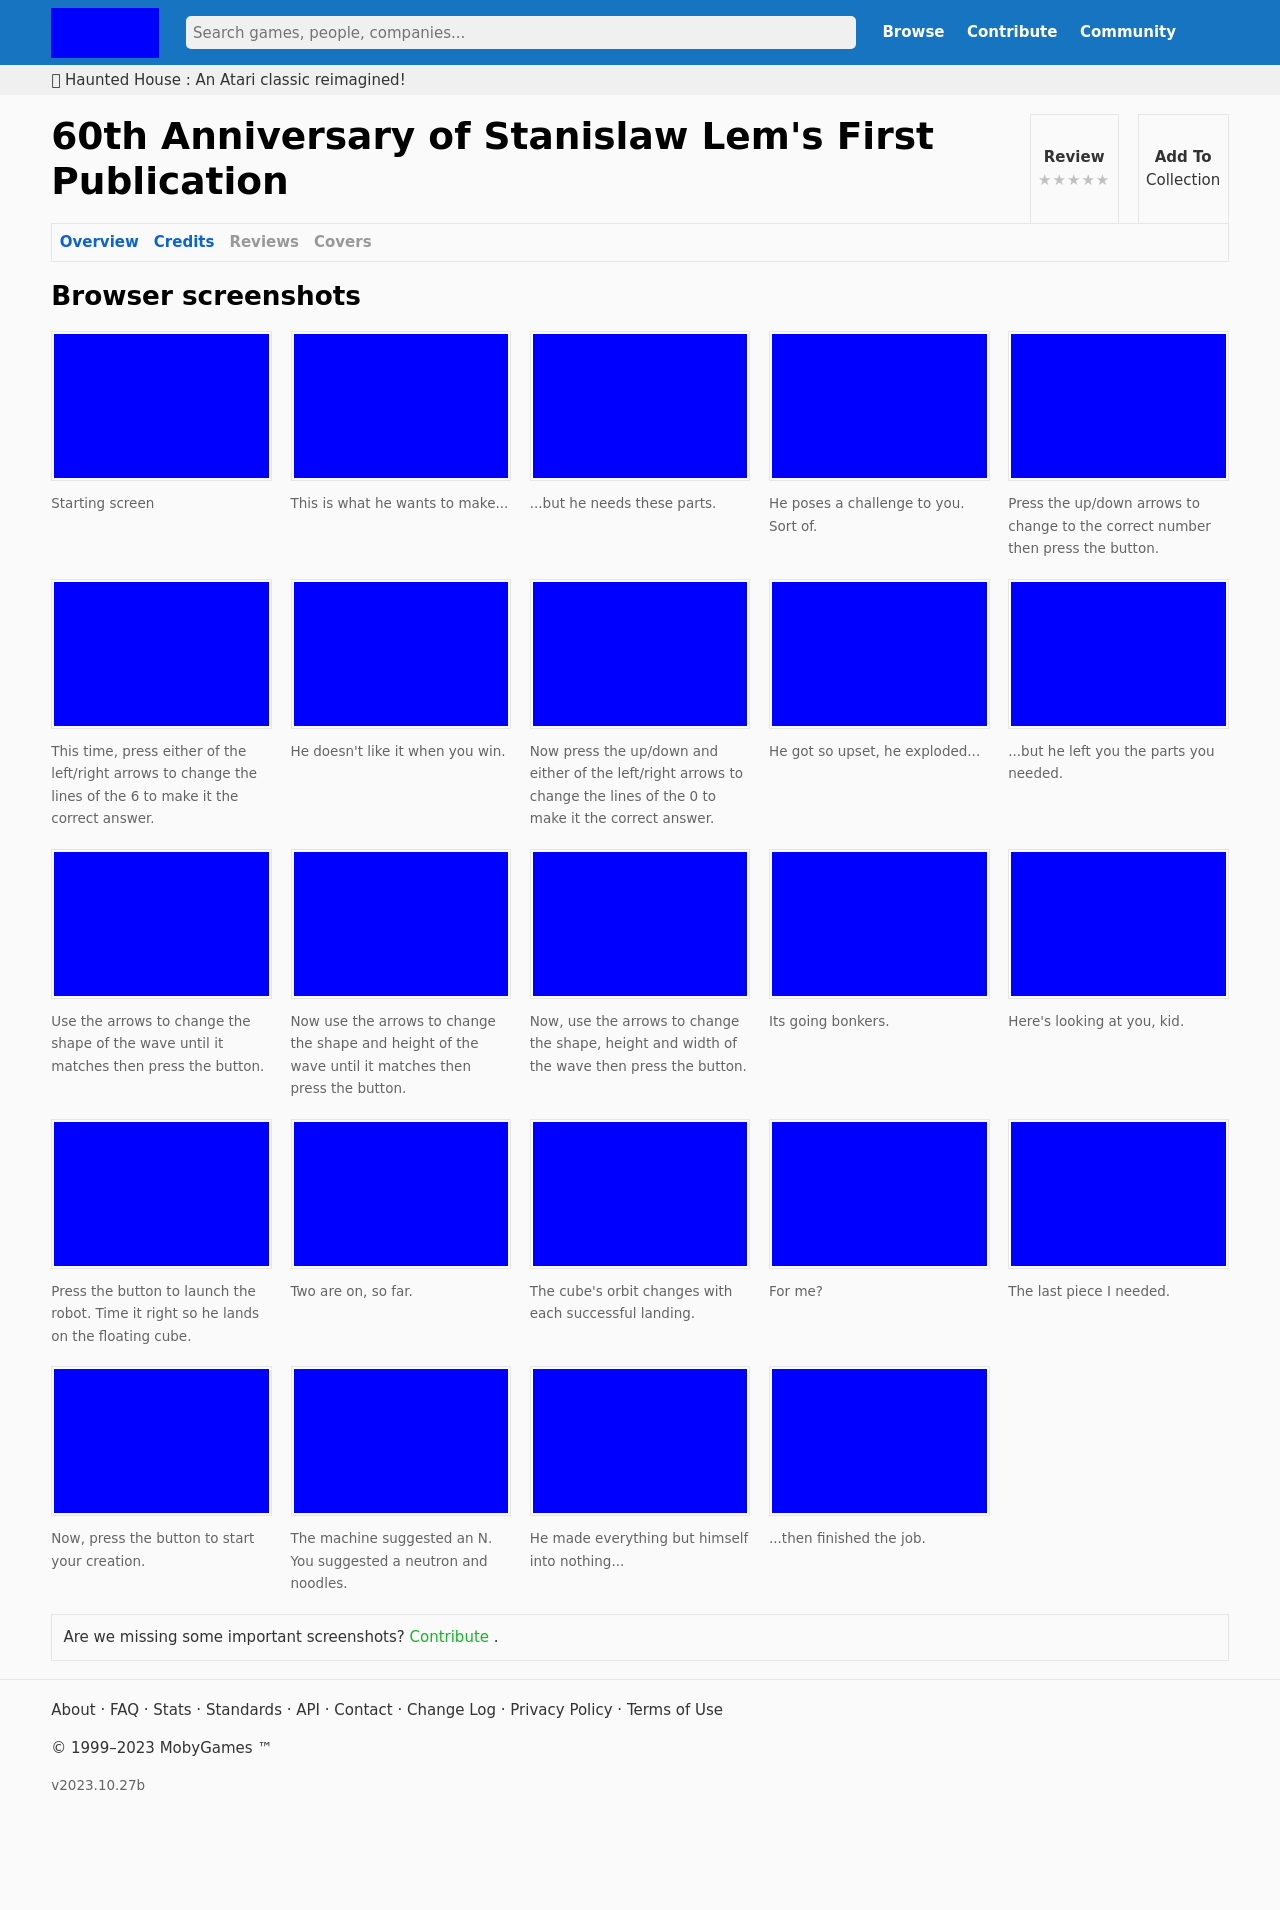Could you guide me through the process of developing this website with HTML? Certainly! To develop a website similar to the one in the image, which appears to be a game-related site displaying screenshots, you would need to use HTML to structure the page, CSS for styling, and possibly JavaScript for any interactive elements. Here's a simple example of how you could structure the HTML:

```
<!DOCTYPE html>
<html>
<head>
    <title>Game Screenshot Gallery</title>
    <link rel="stylesheet" type="text/css" href="styles.css">
</head>
<body>
    <header>
        <h1>Game Screenshot Gallery</h1>
    </header>
    <section>
        <article>
            <img src="screenshot1.jpg" alt="Game Screenshot 1">
            <p>Description of the first screenshot.</p>
        </article>
        <article>
            <img src="screenshot2.jpg" alt="Game Screenshot 2">
            <p>Description of the second screenshot.</p>
        </article>
    </section>
    <footer>
        <p>© 2023 Game Website</p>
    </footer>
</body>
</html>
```

This code snippet provides a basic layout. You would need to create a CSS file named 'styles.css' to style the headers, sections, and images according to your design preferences. 